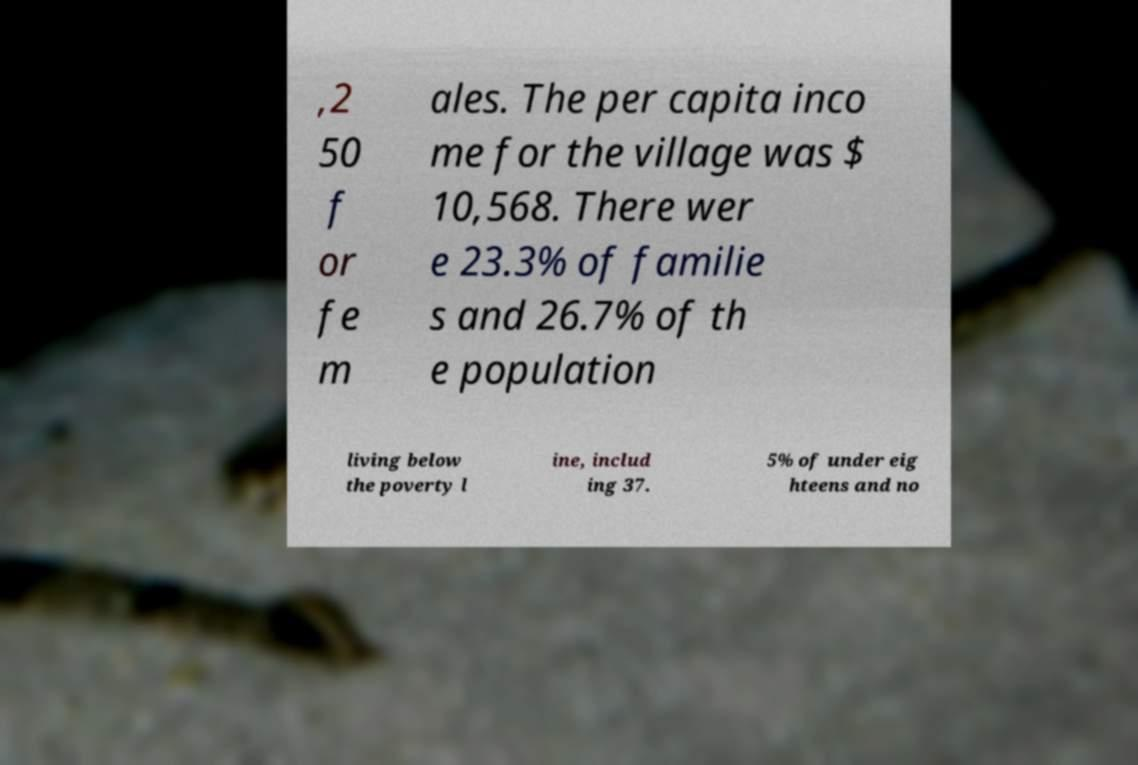Please identify and transcribe the text found in this image. ,2 50 f or fe m ales. The per capita inco me for the village was $ 10,568. There wer e 23.3% of familie s and 26.7% of th e population living below the poverty l ine, includ ing 37. 5% of under eig hteens and no 